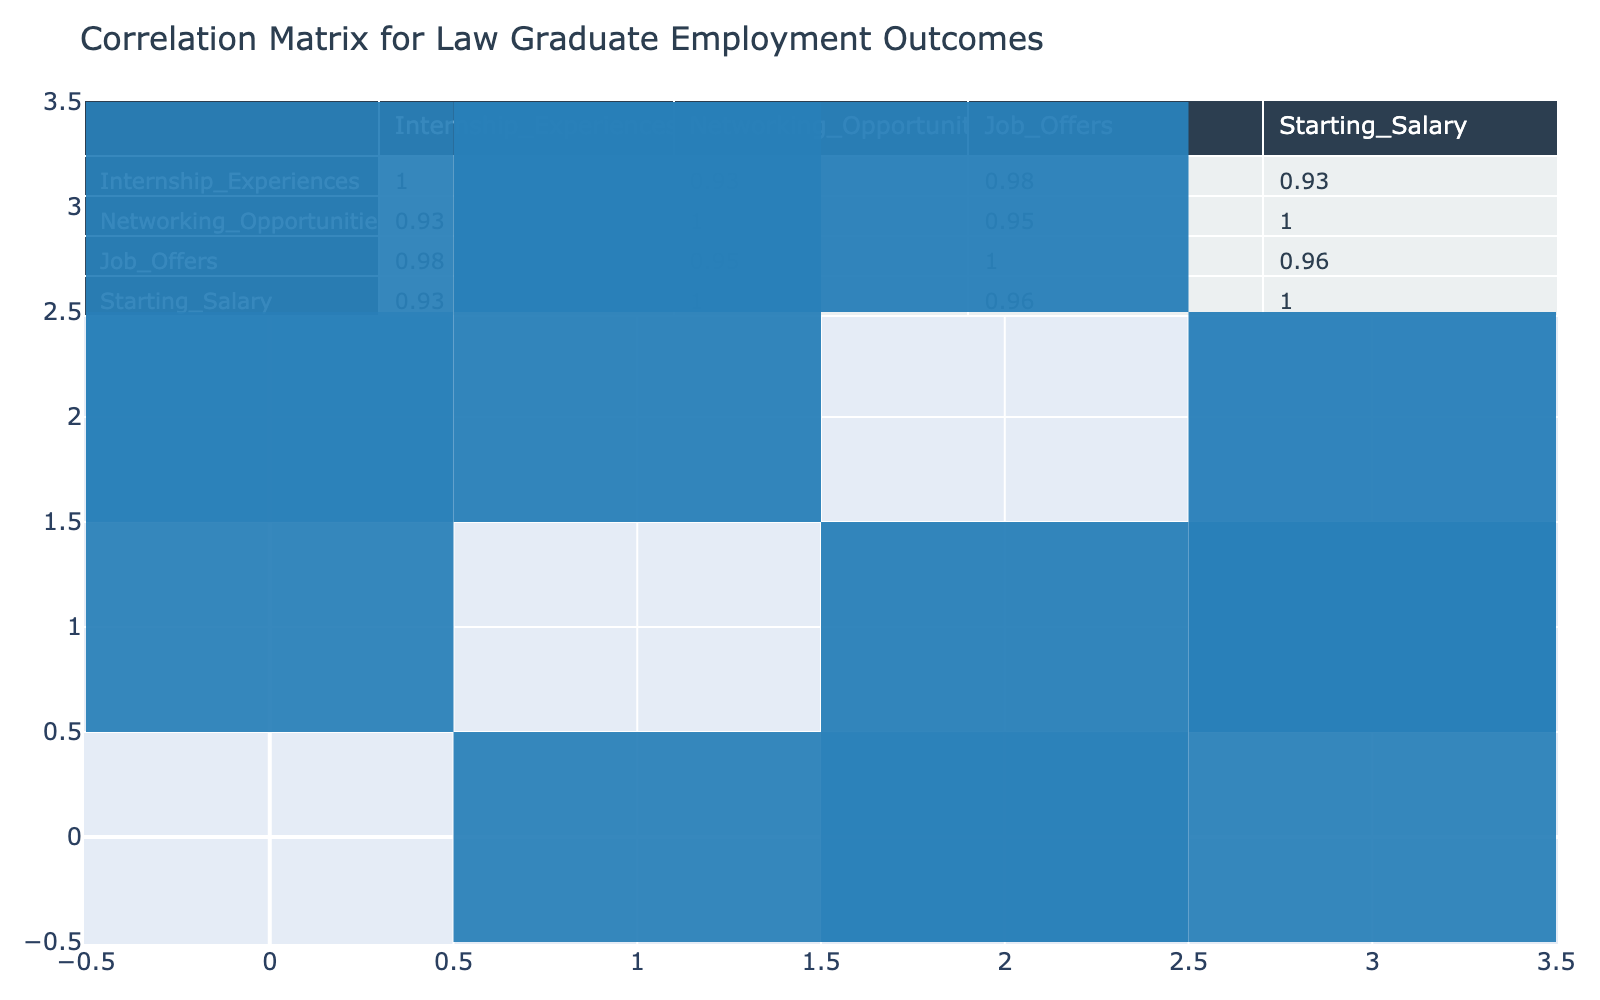What is the correlation between internship experiences and job offers? From the correlation matrix, the value for the correlation between internship experiences and job offers is 0.84, indicating a strong positive correlation.
Answer: 0.84 What is the starting salary for the graduates with the highest internship experience? Looking at the table, the highest internship experience is 5, which corresponds to starting salaries of 80000 and 85000. The highest value is 85000.
Answer: 85000 Is there any relationship between networking opportunities and employment status? The correlation value between networking opportunities and employment status is 0.60. This indicates a moderate positive correlation, suggesting that as networking opportunities increase, so do the chances of being employed.
Answer: Yes What is the average starting salary for employed graduates? The starting salaries for employed graduates are 80000, 65000, 70000, 75000, 85000, 78000. Summing these gives 430000. Dividing by 6 (the number of employed graduates) gives an average of 71666.67, which rounds to 71667.
Answer: 71667 Are unemployed graduates more likely to have lower internship experiences? The average internship experiences for unemployed graduates are (2 + 1 + 2 + 3)/4 = 2, while for employed graduates, it’s higher at 4.17. This supports the idea that unemployed graduates generally have lower internship experiences.
Answer: Yes What is the difference in job offers between graduates with 3 and 5 internship experiences? The job offers for graduates with 3 internship experiences is 4, while for 5 internship experiences, it is 7. The difference is 7 - 4 = 3.
Answer: 3 What is the correlation between job offers and starting salary? The correlation matrix shows the correlation between job offers and starting salary is 0.78, indicating a strong positive correlation. This suggests that more job offers generally lead to higher starting salaries.
Answer: 0.78 Does at least one graduate with 1 internship experience have a job offer? The graduate with 1 internship experience has a job offer value of 1, which is less than the job offers of others but it is still counted as a job offer, therefore yes.
Answer: Yes What is the highest internship experience recorded in the table? Scanning through the internship experiences in the table, the highest recorded value is 5.
Answer: 5 